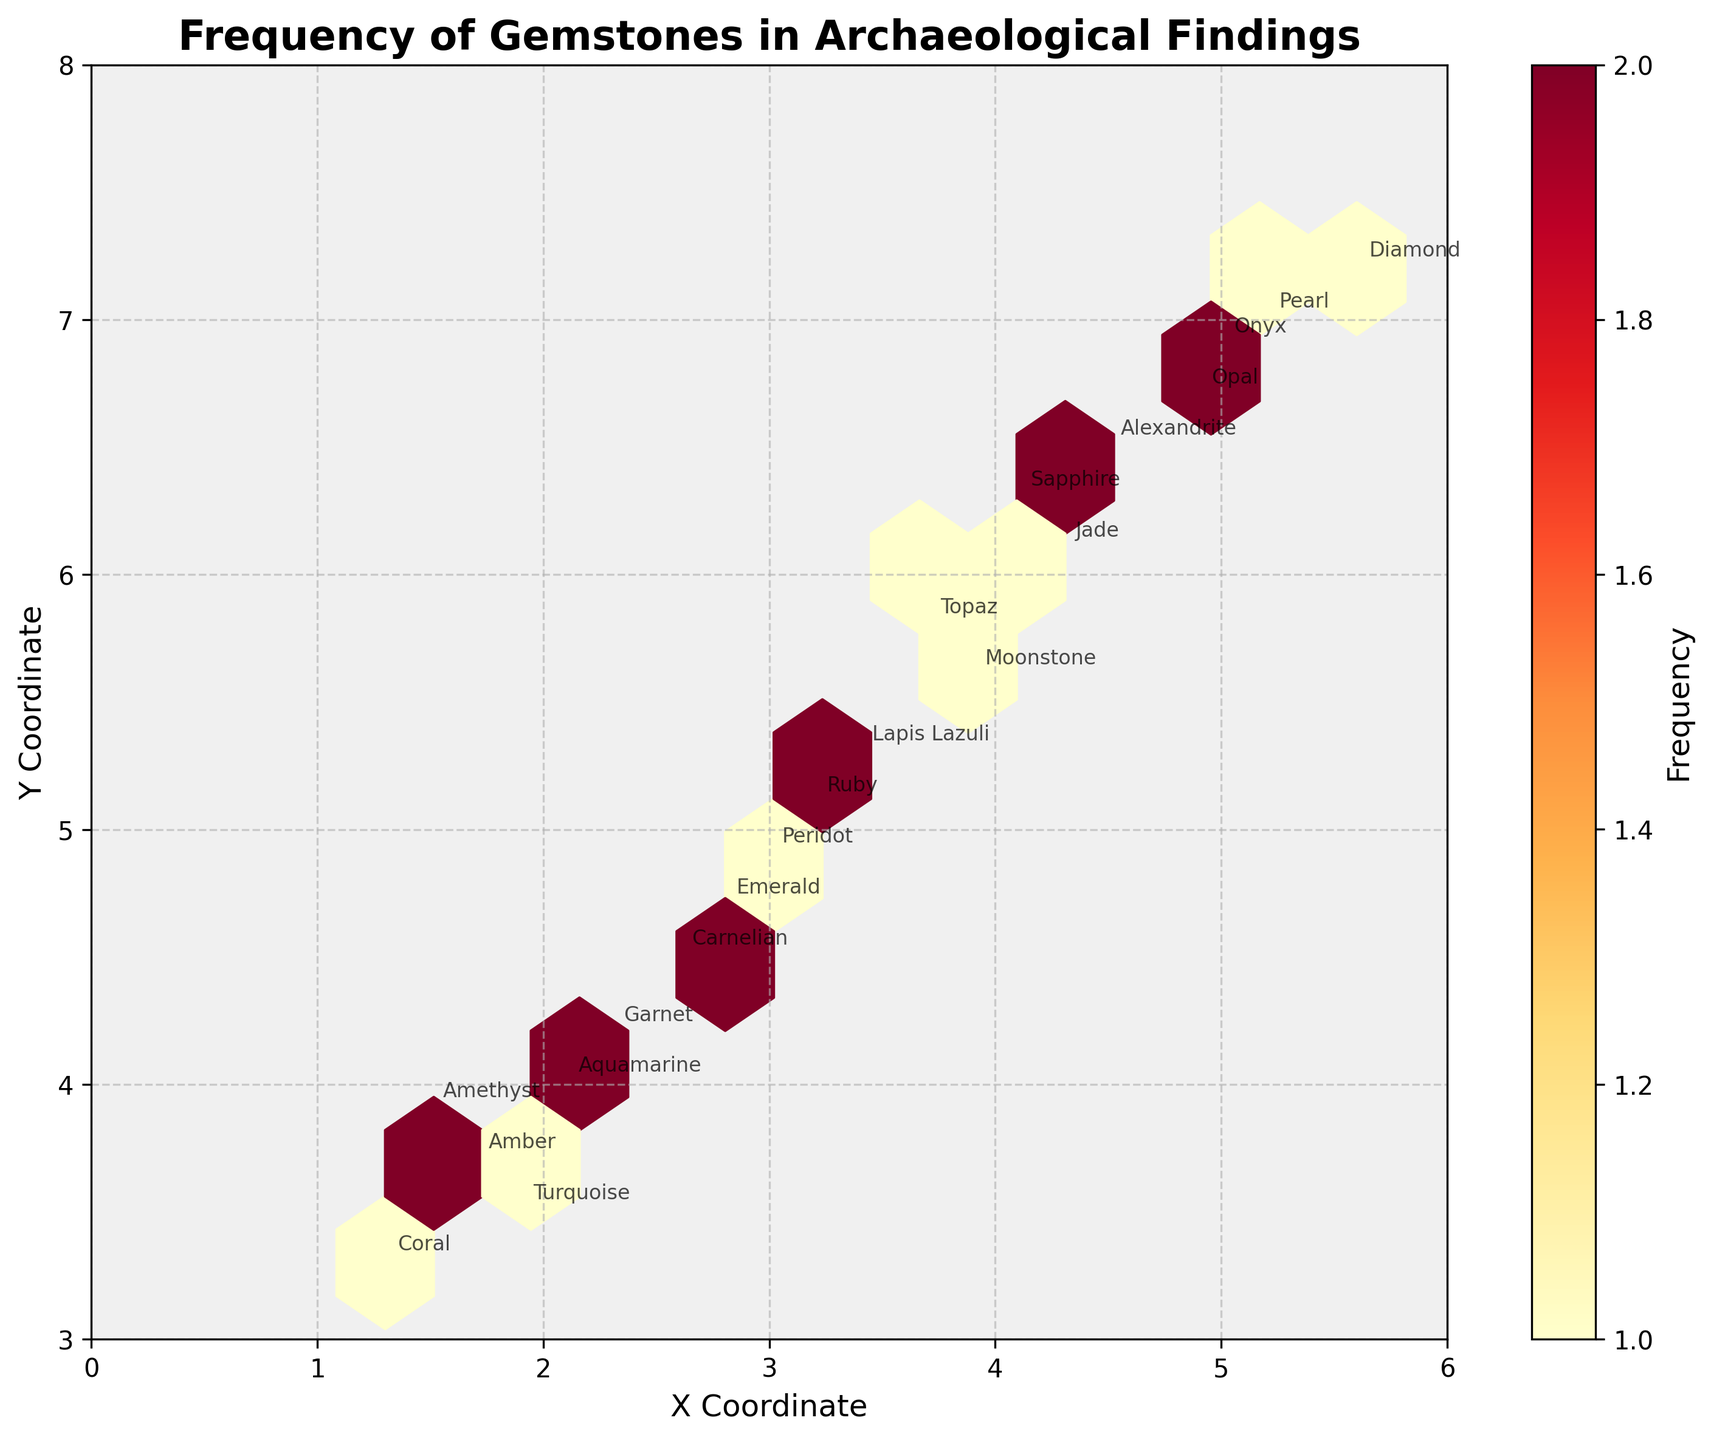What is the title of the hexbin plot? The title of the plot can be found at the top center of the figure.
Answer: Frequency of Gemstones in Archaeological Findings What are the x and y coordinates labeled on the axes? The axes labels are found along the horizontal (x-axis) and vertical (y-axis) lines.
Answer: X Coordinate and Y Coordinate Which gemstone has coordinates (3.2, 5.1)? We can find this by looking for the annotations at coordinates (3.2, 5.1) on the figure.
Answer: Ruby What is the color scheme used in the hexbin plot? The color scheme can be observed in the hexagons and the colorbar legend.
Answer: Yellow to Red (YlOrRd) How many gemstones are found at coordinates around (4.1, 6.3)? Look at the color intensity of the hexagon at (4.1, 6.3) and refer to the colorbar for frequency.
Answer: 1 gemstone Which gemstone is closest to (4, 6) and what are its coordinates? Identify the gemstone annotation nearest to (4, 6) by comparing distances.
Answer: Sapphire, (4.1, 6.3) Is there a cluster of gemstones with y-coordinate in the range of 6 to 7? Examine the plot and identify regions with frequent hexagons and y-coordinates between 6 and 7.
Answer: Yes Which gemstone has the highest y-coordinate? Find the annotation with the highest y-coordinate value.
Answer: Diamond, (5.6, 7.2) How many data points are there in total? Count each unique annotation for gemstones in the plot.
Answer: 20 Which coordinates correspond to Amber in the plot? Locate the annotation "Amber" and note its coordinates.
Answer: (1.7, 3.7) 